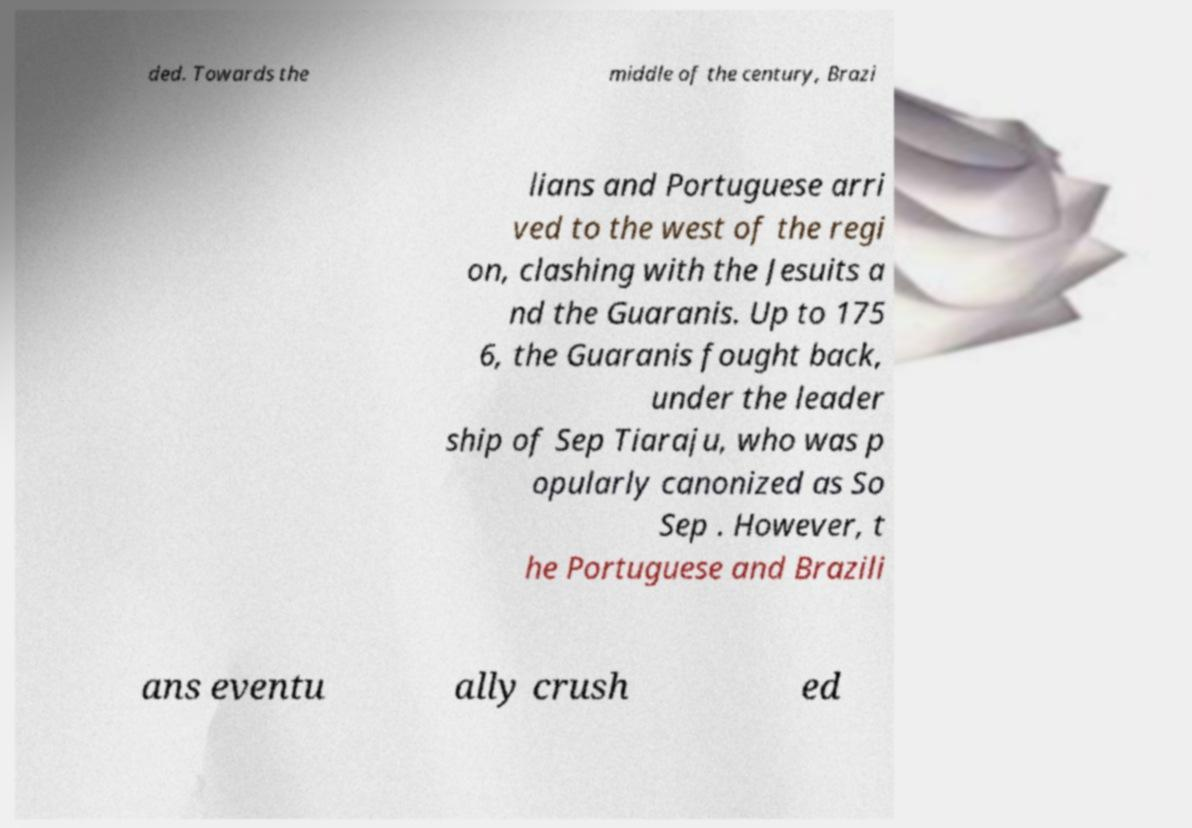What messages or text are displayed in this image? I need them in a readable, typed format. ded. Towards the middle of the century, Brazi lians and Portuguese arri ved to the west of the regi on, clashing with the Jesuits a nd the Guaranis. Up to 175 6, the Guaranis fought back, under the leader ship of Sep Tiaraju, who was p opularly canonized as So Sep . However, t he Portuguese and Brazili ans eventu ally crush ed 